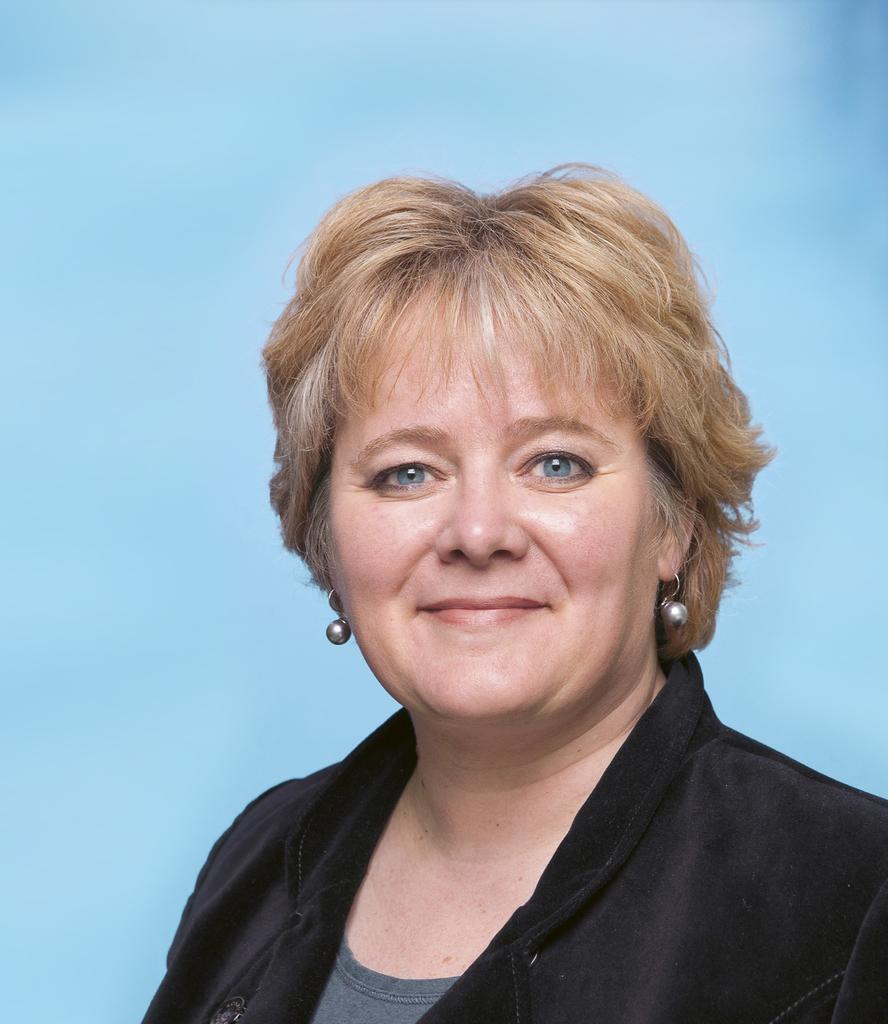Describe this image in one or two sentences. In this picture, we see a woman in white dress is smiling. She might be posing for the photo. She has the blue color eyes. In the background, it is blue in color. 